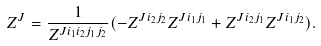<formula> <loc_0><loc_0><loc_500><loc_500>Z ^ { J } = \frac { 1 } { Z ^ { J i _ { 1 } i _ { 2 } j _ { 1 } j _ { 2 } } } ( - Z ^ { J i _ { 2 } j _ { 2 } } Z ^ { J i _ { 1 } j _ { 1 } } + Z ^ { J i _ { 2 } j _ { 1 } } Z ^ { J i _ { 1 } j _ { 2 } } ) .</formula> 